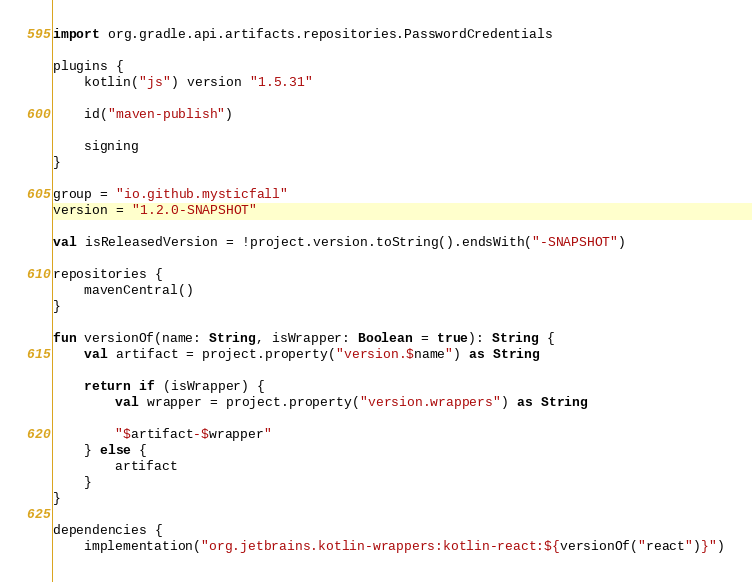<code> <loc_0><loc_0><loc_500><loc_500><_Kotlin_>import org.gradle.api.artifacts.repositories.PasswordCredentials

plugins {
    kotlin("js") version "1.5.31"

    id("maven-publish")

    signing
}

group = "io.github.mysticfall"
version = "1.2.0-SNAPSHOT"

val isReleasedVersion = !project.version.toString().endsWith("-SNAPSHOT")

repositories {
    mavenCentral()
}

fun versionOf(name: String, isWrapper: Boolean = true): String {
    val artifact = project.property("version.$name") as String

    return if (isWrapper) {
        val wrapper = project.property("version.wrappers") as String

        "$artifact-$wrapper"
    } else {
        artifact
    }
}

dependencies {
    implementation("org.jetbrains.kotlin-wrappers:kotlin-react:${versionOf("react")}")</code> 